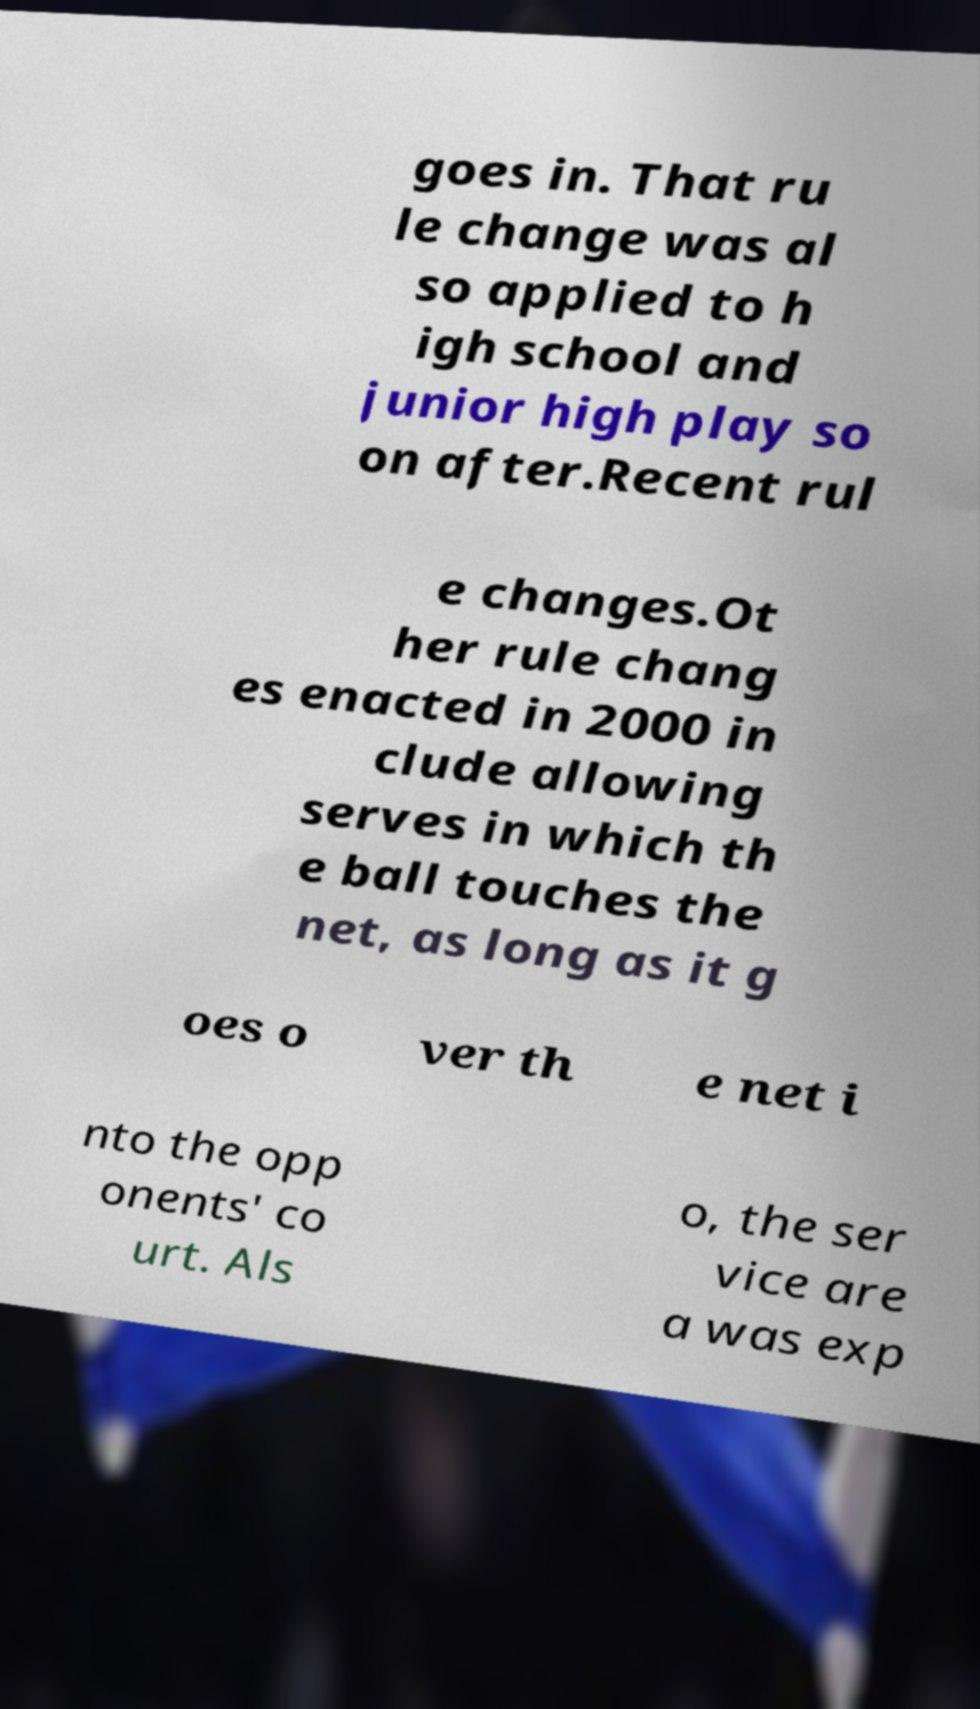Could you extract and type out the text from this image? goes in. That ru le change was al so applied to h igh school and junior high play so on after.Recent rul e changes.Ot her rule chang es enacted in 2000 in clude allowing serves in which th e ball touches the net, as long as it g oes o ver th e net i nto the opp onents' co urt. Als o, the ser vice are a was exp 